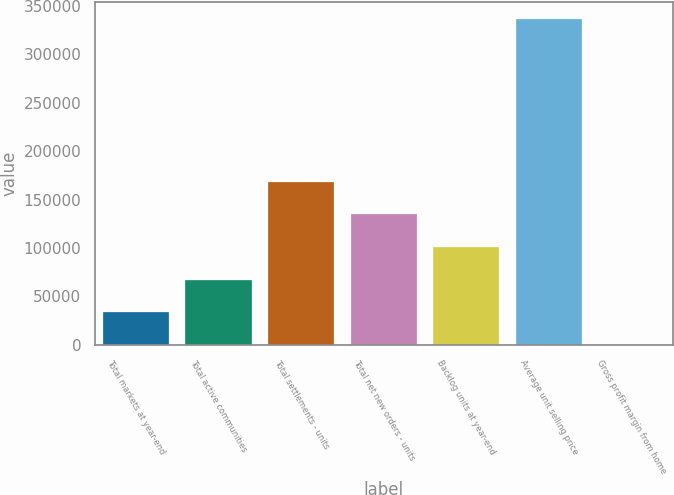Convert chart. <chart><loc_0><loc_0><loc_500><loc_500><bar_chart><fcel>Total markets at year-end<fcel>Total active communities<fcel>Total settlements - units<fcel>Total net new orders - units<fcel>Backlog units at year-end<fcel>Average unit selling price<fcel>Gross profit margin from home<nl><fcel>33715.7<fcel>67413.9<fcel>168509<fcel>134810<fcel>101112<fcel>337000<fcel>17.4<nl></chart> 